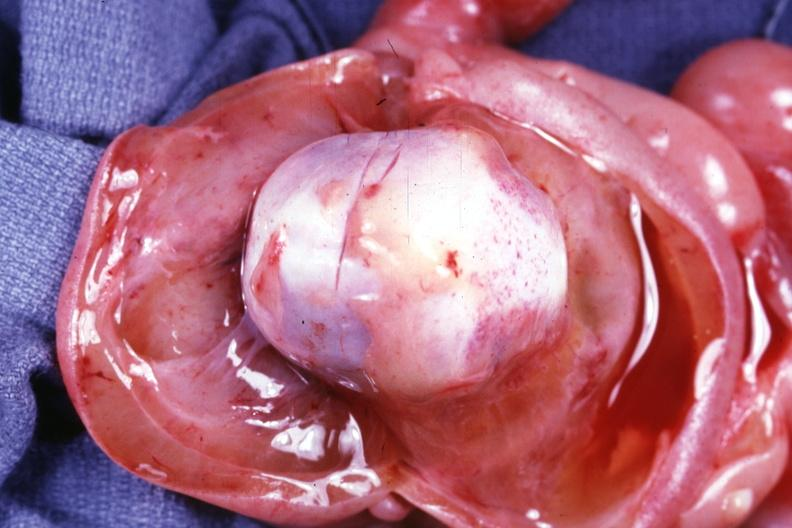what is present?
Answer the question using a single word or phrase. Lymphangiomatosis 